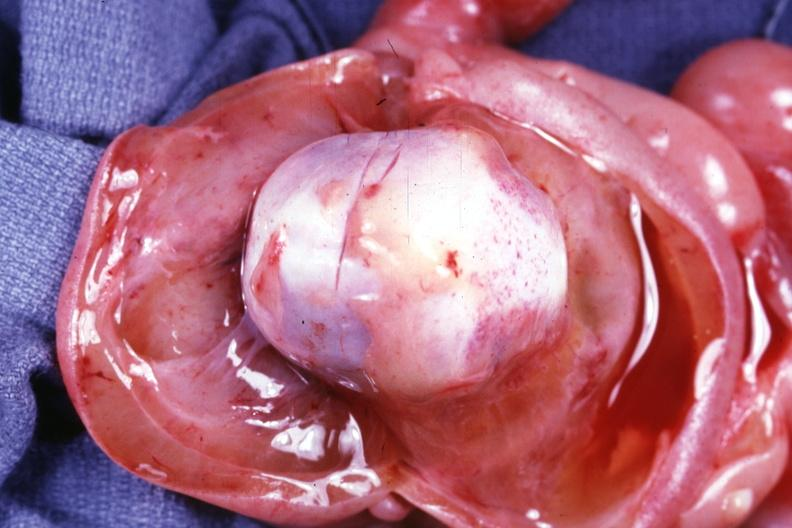what is present?
Answer the question using a single word or phrase. Lymphangiomatosis 